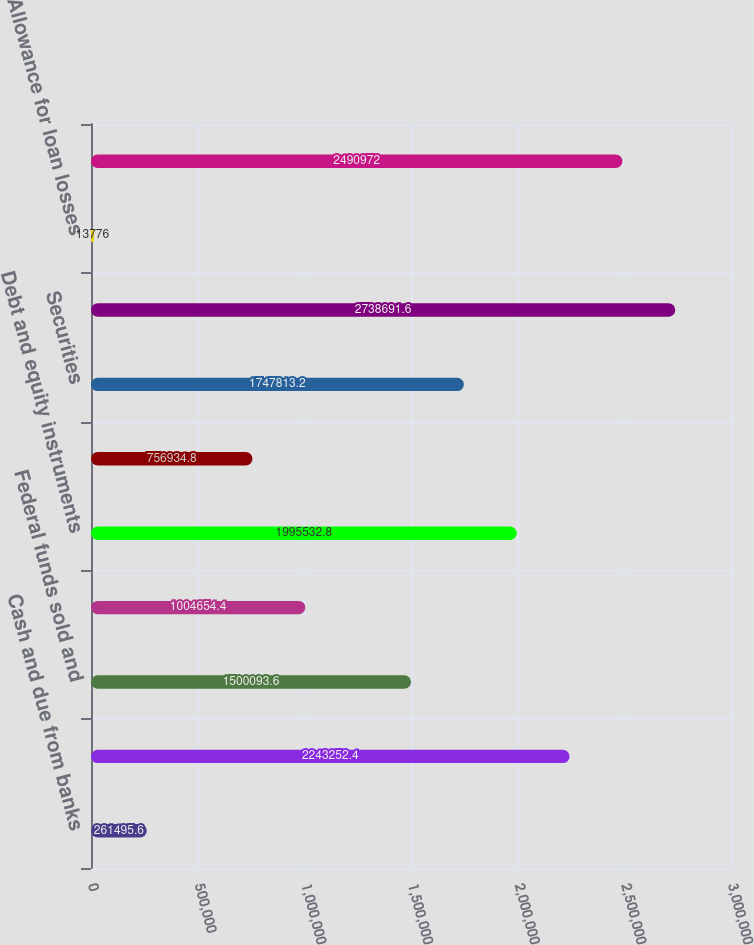Convert chart to OTSL. <chart><loc_0><loc_0><loc_500><loc_500><bar_chart><fcel>Cash and due from banks<fcel>Deposits with banks<fcel>Federal funds sold and<fcel>Securities borrowed<fcel>Debt and equity instruments<fcel>Derivative receivables<fcel>Securities<fcel>Loans<fcel>Allowance for loan losses<fcel>Loans net of allowance for<nl><fcel>261496<fcel>2.24325e+06<fcel>1.50009e+06<fcel>1.00465e+06<fcel>1.99553e+06<fcel>756935<fcel>1.74781e+06<fcel>2.73869e+06<fcel>13776<fcel>2.49097e+06<nl></chart> 